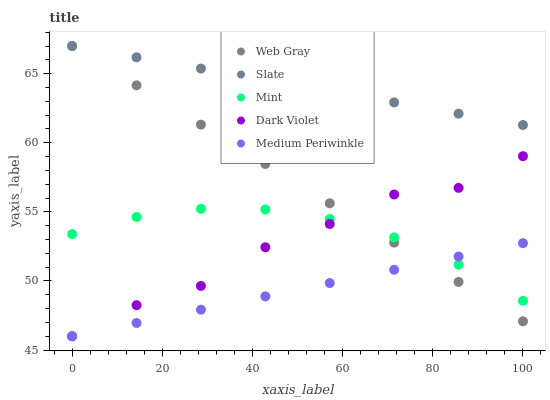Does Medium Periwinkle have the minimum area under the curve?
Answer yes or no. Yes. Does Slate have the maximum area under the curve?
Answer yes or no. Yes. Does Web Gray have the minimum area under the curve?
Answer yes or no. No. Does Web Gray have the maximum area under the curve?
Answer yes or no. No. Is Medium Periwinkle the smoothest?
Answer yes or no. Yes. Is Dark Violet the roughest?
Answer yes or no. Yes. Is Slate the smoothest?
Answer yes or no. No. Is Slate the roughest?
Answer yes or no. No. Does Medium Periwinkle have the lowest value?
Answer yes or no. Yes. Does Web Gray have the lowest value?
Answer yes or no. No. Does Web Gray have the highest value?
Answer yes or no. Yes. Does Mint have the highest value?
Answer yes or no. No. Is Mint less than Slate?
Answer yes or no. Yes. Is Slate greater than Mint?
Answer yes or no. Yes. Does Web Gray intersect Dark Violet?
Answer yes or no. Yes. Is Web Gray less than Dark Violet?
Answer yes or no. No. Is Web Gray greater than Dark Violet?
Answer yes or no. No. Does Mint intersect Slate?
Answer yes or no. No. 